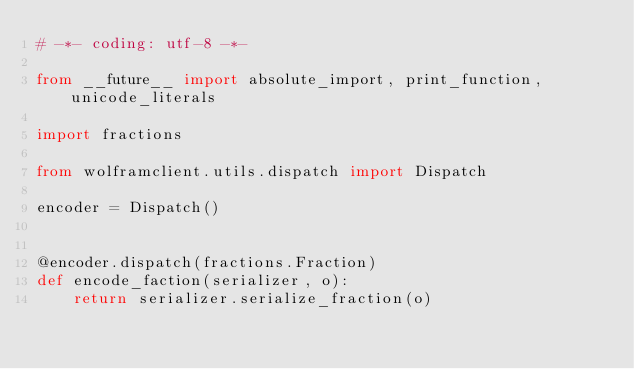<code> <loc_0><loc_0><loc_500><loc_500><_Python_># -*- coding: utf-8 -*-

from __future__ import absolute_import, print_function, unicode_literals

import fractions

from wolframclient.utils.dispatch import Dispatch

encoder = Dispatch()


@encoder.dispatch(fractions.Fraction)
def encode_faction(serializer, o):
    return serializer.serialize_fraction(o)
</code> 